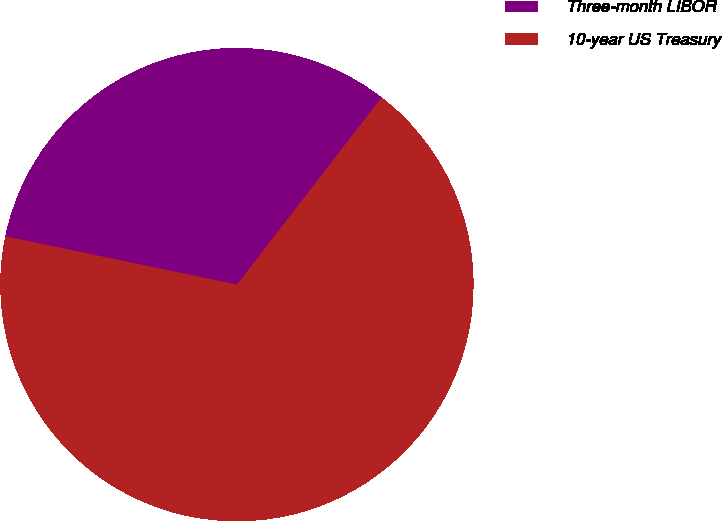<chart> <loc_0><loc_0><loc_500><loc_500><pie_chart><fcel>Three-month LIBOR<fcel>10-year US Treasury<nl><fcel>32.2%<fcel>67.8%<nl></chart> 